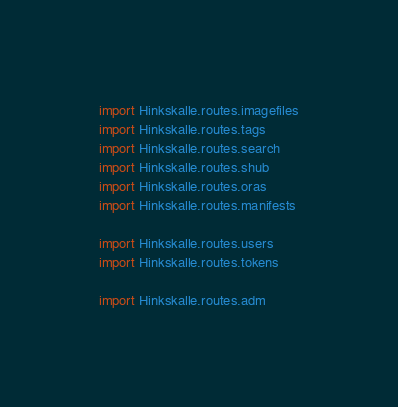<code> <loc_0><loc_0><loc_500><loc_500><_Python_>import Hinkskalle.routes.imagefiles
import Hinkskalle.routes.tags
import Hinkskalle.routes.search
import Hinkskalle.routes.shub
import Hinkskalle.routes.oras
import Hinkskalle.routes.manifests

import Hinkskalle.routes.users
import Hinkskalle.routes.tokens

import Hinkskalle.routes.adm</code> 